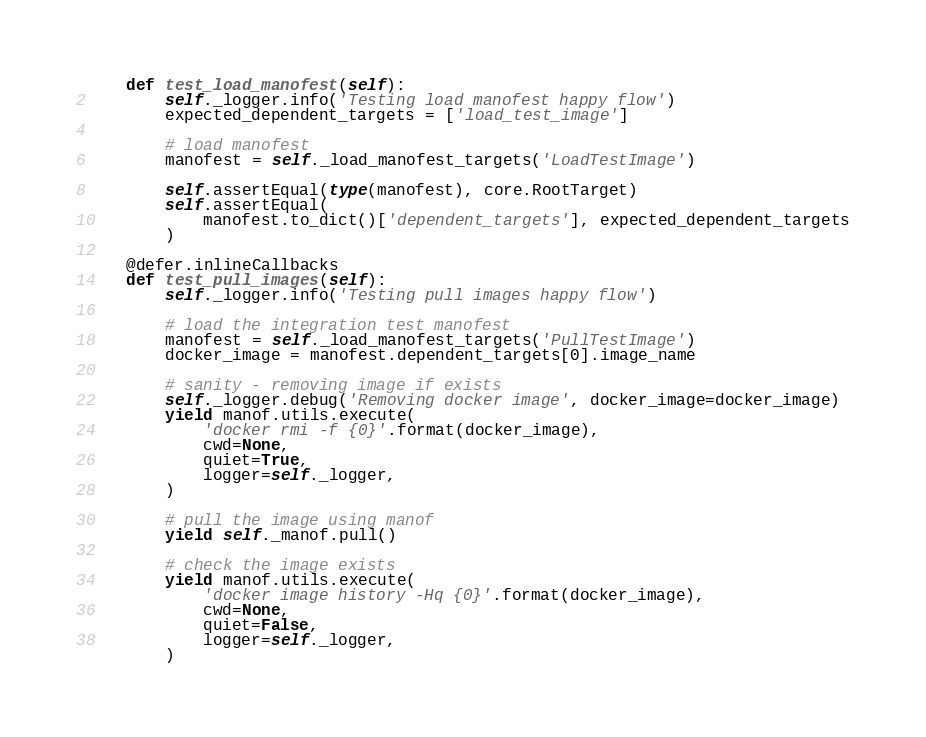Convert code to text. <code><loc_0><loc_0><loc_500><loc_500><_Python_>    def test_load_manofest(self):
        self._logger.info('Testing load manofest happy flow')
        expected_dependent_targets = ['load_test_image']

        # load manofest
        manofest = self._load_manofest_targets('LoadTestImage')

        self.assertEqual(type(manofest), core.RootTarget)
        self.assertEqual(
            manofest.to_dict()['dependent_targets'], expected_dependent_targets
        )

    @defer.inlineCallbacks
    def test_pull_images(self):
        self._logger.info('Testing pull images happy flow')

        # load the integration test manofest
        manofest = self._load_manofest_targets('PullTestImage')
        docker_image = manofest.dependent_targets[0].image_name

        # sanity - removing image if exists
        self._logger.debug('Removing docker image', docker_image=docker_image)
        yield manof.utils.execute(
            'docker rmi -f {0}'.format(docker_image),
            cwd=None,
            quiet=True,
            logger=self._logger,
        )

        # pull the image using manof
        yield self._manof.pull()

        # check the image exists
        yield manof.utils.execute(
            'docker image history -Hq {0}'.format(docker_image),
            cwd=None,
            quiet=False,
            logger=self._logger,
        )
</code> 